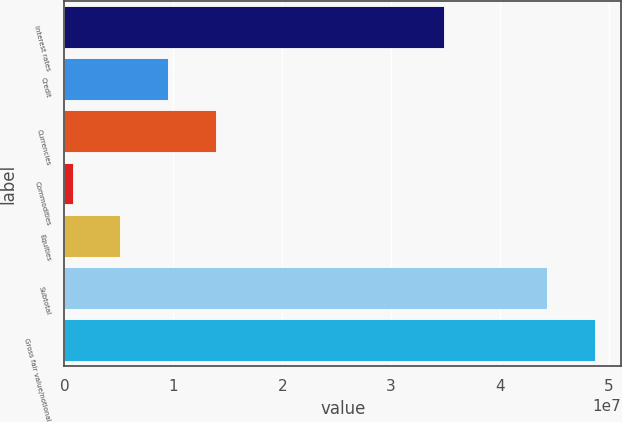<chart> <loc_0><loc_0><loc_500><loc_500><bar_chart><fcel>Interest rates<fcel>Credit<fcel>Currencies<fcel>Commodities<fcel>Equities<fcel>Subtotal<fcel>Gross fair value/notional<nl><fcel>3.48918e+07<fcel>9.51003e+06<fcel>1.3878e+07<fcel>774115<fcel>5.14207e+06<fcel>4.43169e+07<fcel>4.86849e+07<nl></chart> 